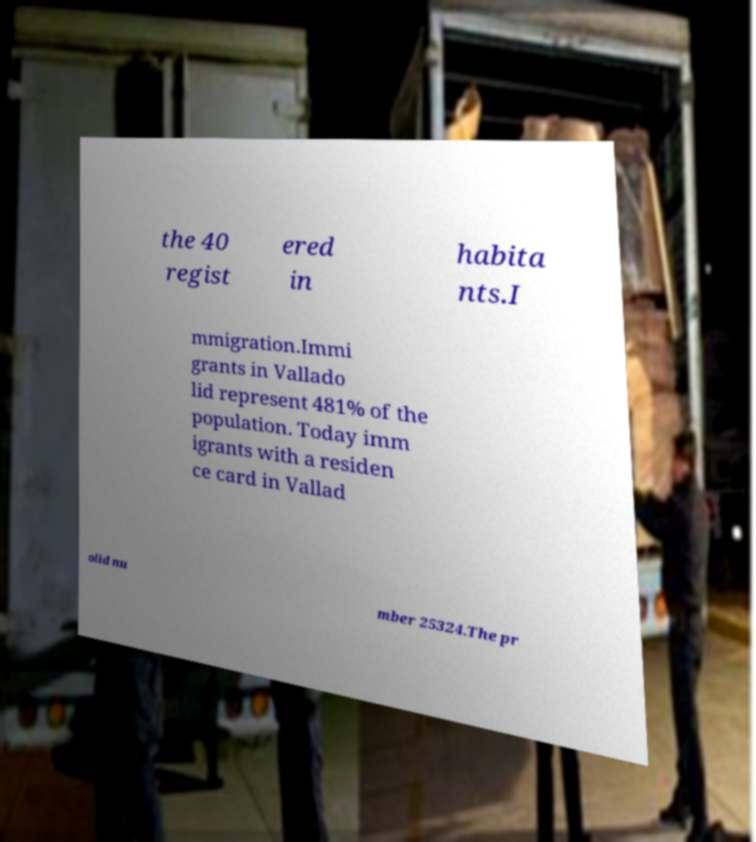What messages or text are displayed in this image? I need them in a readable, typed format. the 40 regist ered in habita nts.I mmigration.Immi grants in Vallado lid represent 481% of the population. Today imm igrants with a residen ce card in Vallad olid nu mber 25324.The pr 